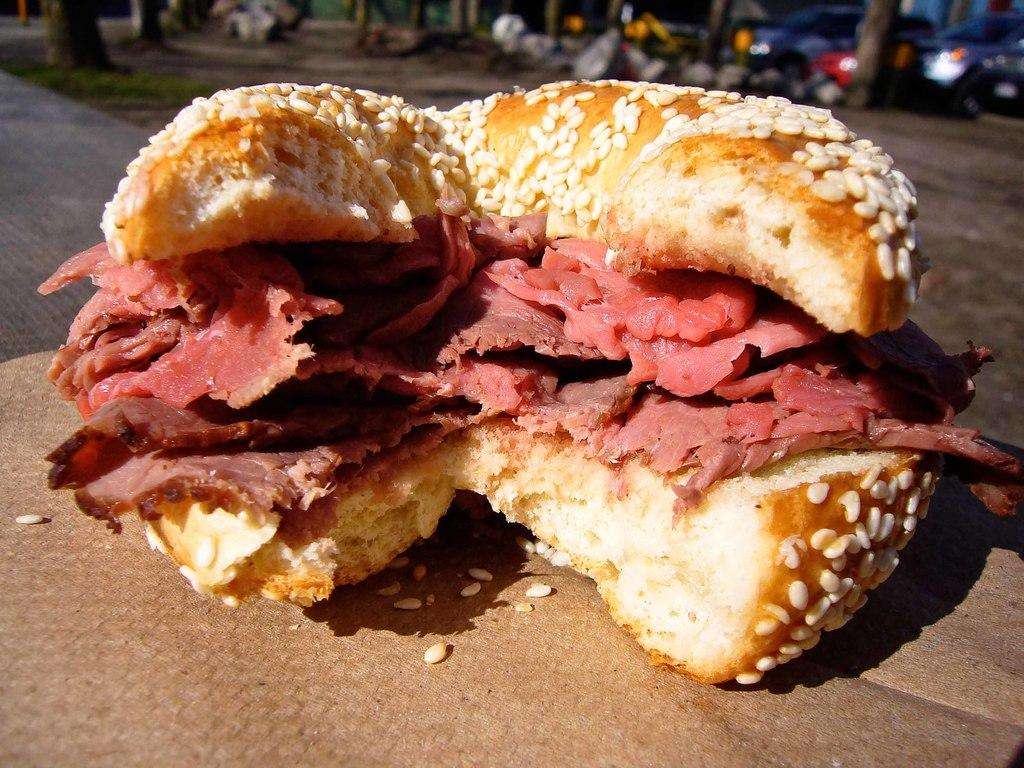What is on the wooden surface in the image? There is food on a wooden surface in the image. How would you describe the background of the image? The background of the image is blurry. What can be seen in the distance in the image? Vehicles and tree trunks are visible in the background of the image. What is the ground like in the image? The ground is visible in the background of the image. How many clocks are hanging on the tree trunks in the image? There are no clocks visible on the tree trunks in the image. What type of cap is being worn by the person in the image? There is no person present in the image, so it is not possible to determine if they are wearing a cap. 